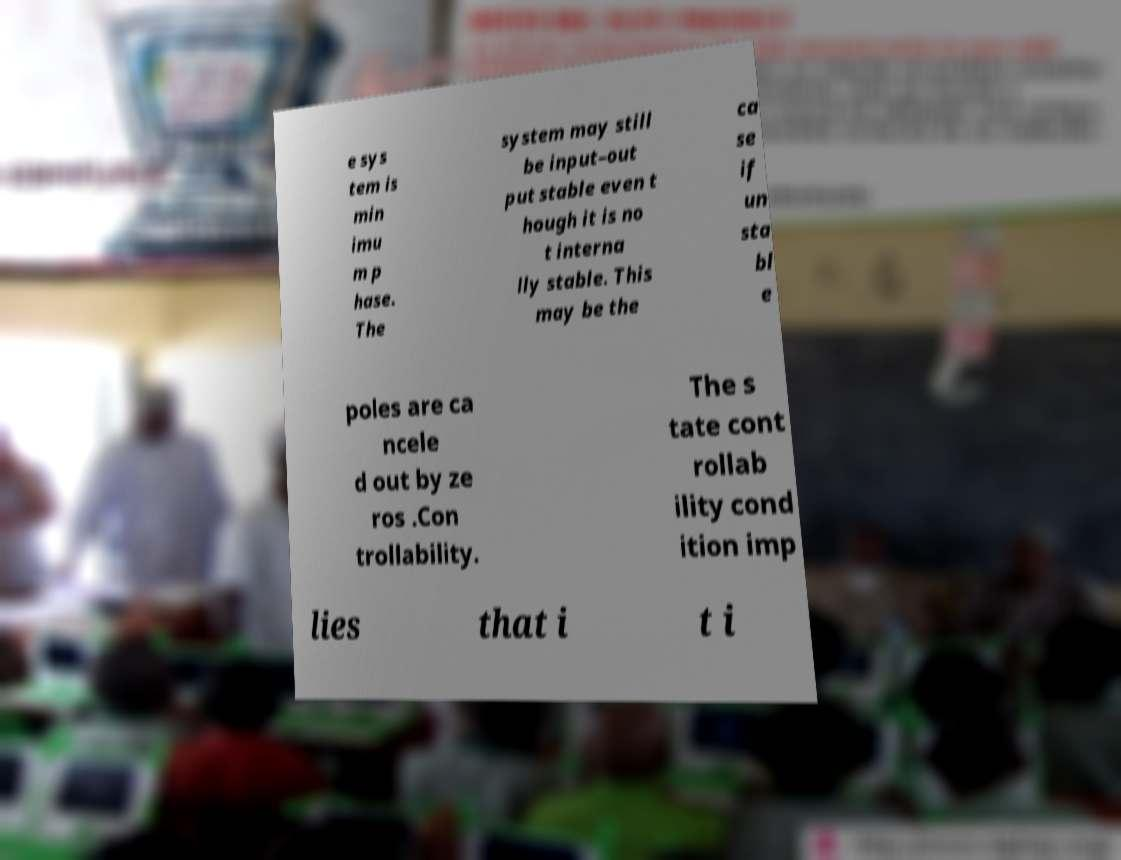There's text embedded in this image that I need extracted. Can you transcribe it verbatim? e sys tem is min imu m p hase. The system may still be input–out put stable even t hough it is no t interna lly stable. This may be the ca se if un sta bl e poles are ca ncele d out by ze ros .Con trollability. The s tate cont rollab ility cond ition imp lies that i t i 